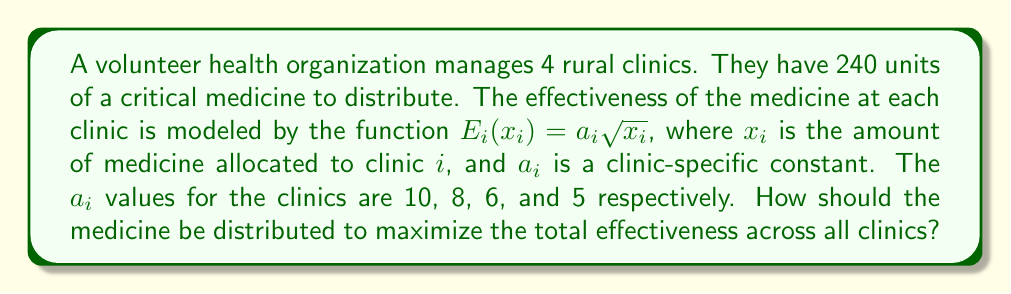Solve this math problem. To solve this optimization problem, we'll use the method of Lagrange multipliers:

1) Let's define our objective function:
   $$E_{total} = 10\sqrt{x_1} + 8\sqrt{x_2} + 6\sqrt{x_3} + 5\sqrt{x_4}$$

2) Our constraint is:
   $$x_1 + x_2 + x_3 + x_4 = 240$$

3) We form the Lagrangian:
   $$L = 10\sqrt{x_1} + 8\sqrt{x_2} + 6\sqrt{x_3} + 5\sqrt{x_4} - \lambda(x_1 + x_2 + x_3 + x_4 - 240)$$

4) We take partial derivatives and set them equal to zero:
   $$\frac{\partial L}{\partial x_1} = \frac{5}{\sqrt{x_1}} - \lambda = 0$$
   $$\frac{\partial L}{\partial x_2} = \frac{4}{\sqrt{x_2}} - \lambda = 0$$
   $$\frac{\partial L}{\partial x_3} = \frac{3}{\sqrt{x_3}} - \lambda = 0$$
   $$\frac{\partial L}{\partial x_4} = \frac{5}{2\sqrt{x_4}} - \lambda = 0$$

5) From these equations, we can deduce:
   $$\frac{5}{\sqrt{x_1}} = \frac{4}{\sqrt{x_2}} = \frac{3}{\sqrt{x_3}} = \frac{5}{2\sqrt{x_4}} = \lambda$$

6) This implies:
   $$x_1 : x_2 : x_3 : x_4 = 10^2 : 8^2 : 6^2 : 5^2 = 100 : 64 : 36 : 25$$

7) Let $k$ be a constant. Then:
   $$x_1 = 100k, x_2 = 64k, x_3 = 36k, x_4 = 25k$$

8) Substituting into our constraint equation:
   $$100k + 64k + 36k + 25k = 240$$
   $$225k = 240$$
   $$k = \frac{16}{15}$$

9) Therefore, the optimal distribution is:
   $$x_1 = 100 \cdot \frac{16}{15} = \frac{1600}{15} \approx 106.67$$
   $$x_2 = 64 \cdot \frac{16}{15} = \frac{1024}{15} \approx 68.27$$
   $$x_3 = 36 \cdot \frac{16}{15} = \frac{576}{15} \approx 38.40$$
   $$x_4 = 25 \cdot \frac{16}{15} = \frac{400}{15} \approx 26.67$$
Answer: The optimal distribution of medicine is approximately:
Clinic 1: 106.67 units
Clinic 2: 68.27 units
Clinic 3: 38.40 units
Clinic 4: 26.67 units 